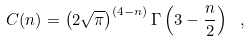<formula> <loc_0><loc_0><loc_500><loc_500>C ( n ) = \left ( 2 \sqrt { \pi } \right ) ^ { ( 4 - n ) } \Gamma \left ( 3 - \frac { n } { 2 } \right ) \ ,</formula> 